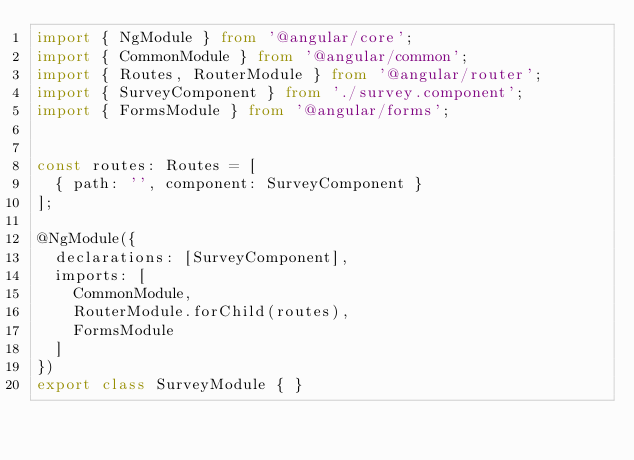Convert code to text. <code><loc_0><loc_0><loc_500><loc_500><_TypeScript_>import { NgModule } from '@angular/core';
import { CommonModule } from '@angular/common';
import { Routes, RouterModule } from '@angular/router';
import { SurveyComponent } from './survey.component';
import { FormsModule } from '@angular/forms';


const routes: Routes = [
  { path: '', component: SurveyComponent }
];

@NgModule({
  declarations: [SurveyComponent],
  imports: [
    CommonModule,
    RouterModule.forChild(routes),
    FormsModule
  ]
})
export class SurveyModule { }
</code> 